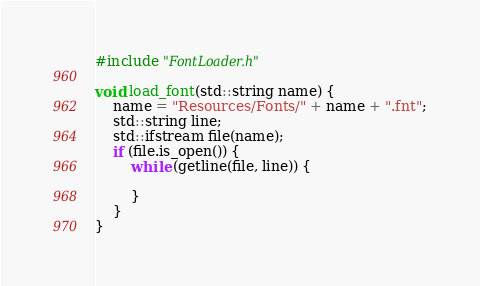Convert code to text. <code><loc_0><loc_0><loc_500><loc_500><_C++_>#include "FontLoader.h"

void load_font(std::string name) {
	name = "Resources/Fonts/" + name + ".fnt";
	std::string line;
	std::ifstream file(name);
	if (file.is_open()) {
		while (getline(file, line)) {
			
		}
	}
}</code> 